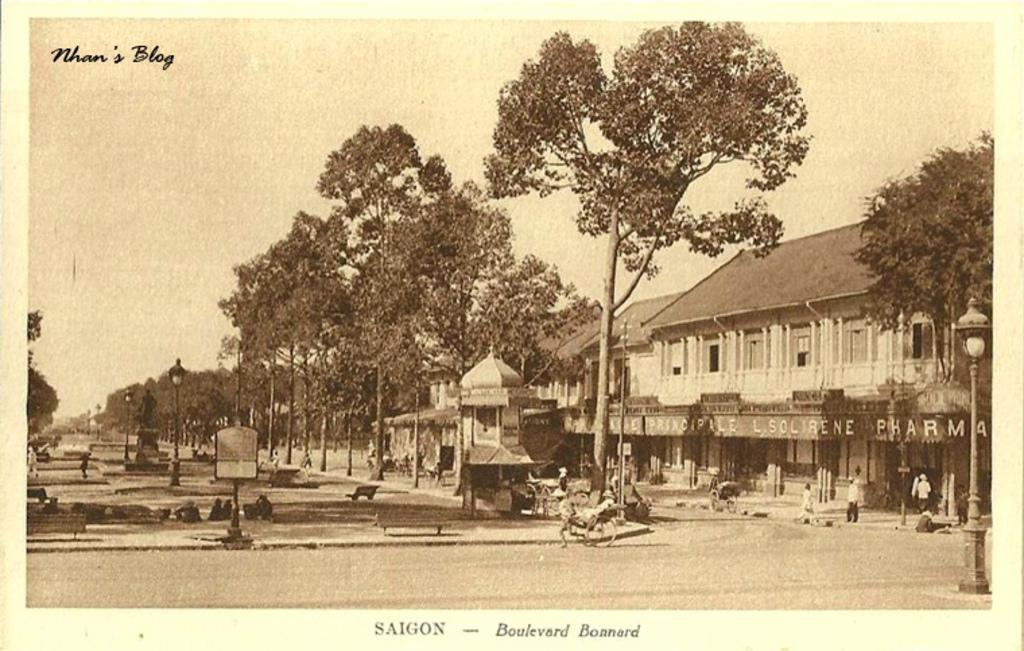In one or two sentences, can you explain what this image depicts? This is a poster having texts and an image. In this image, we can see there is a person holding a trolley and running on a road, there are buildings, poles, persons, trees, grass, benches, a statue and there are clouds in the sky. 